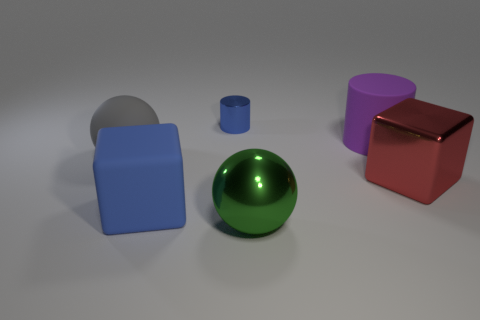Are the blue cylinder and the sphere to the right of the large blue cube made of the same material?
Give a very brief answer. Yes. What number of other objects are the same shape as the big gray matte object?
Make the answer very short. 1. What material is the cylinder that is the same color as the large matte block?
Offer a very short reply. Metal. How many shiny blocks are there?
Offer a very short reply. 1. Is the shape of the tiny metallic thing the same as the big object behind the large gray thing?
Make the answer very short. Yes. What number of things are blue metallic things or big things that are in front of the large red metallic cube?
Your answer should be very brief. 3. There is a large thing that is the same shape as the tiny metallic thing; what is it made of?
Make the answer very short. Rubber. There is a blue thing that is behind the large purple object; is its shape the same as the large blue thing?
Ensure brevity in your answer.  No. Is there any other thing that is the same size as the green ball?
Your response must be concise. Yes. Is the number of red shiny things that are to the left of the big green shiny thing less than the number of large purple matte cylinders to the left of the large gray matte ball?
Ensure brevity in your answer.  No. 